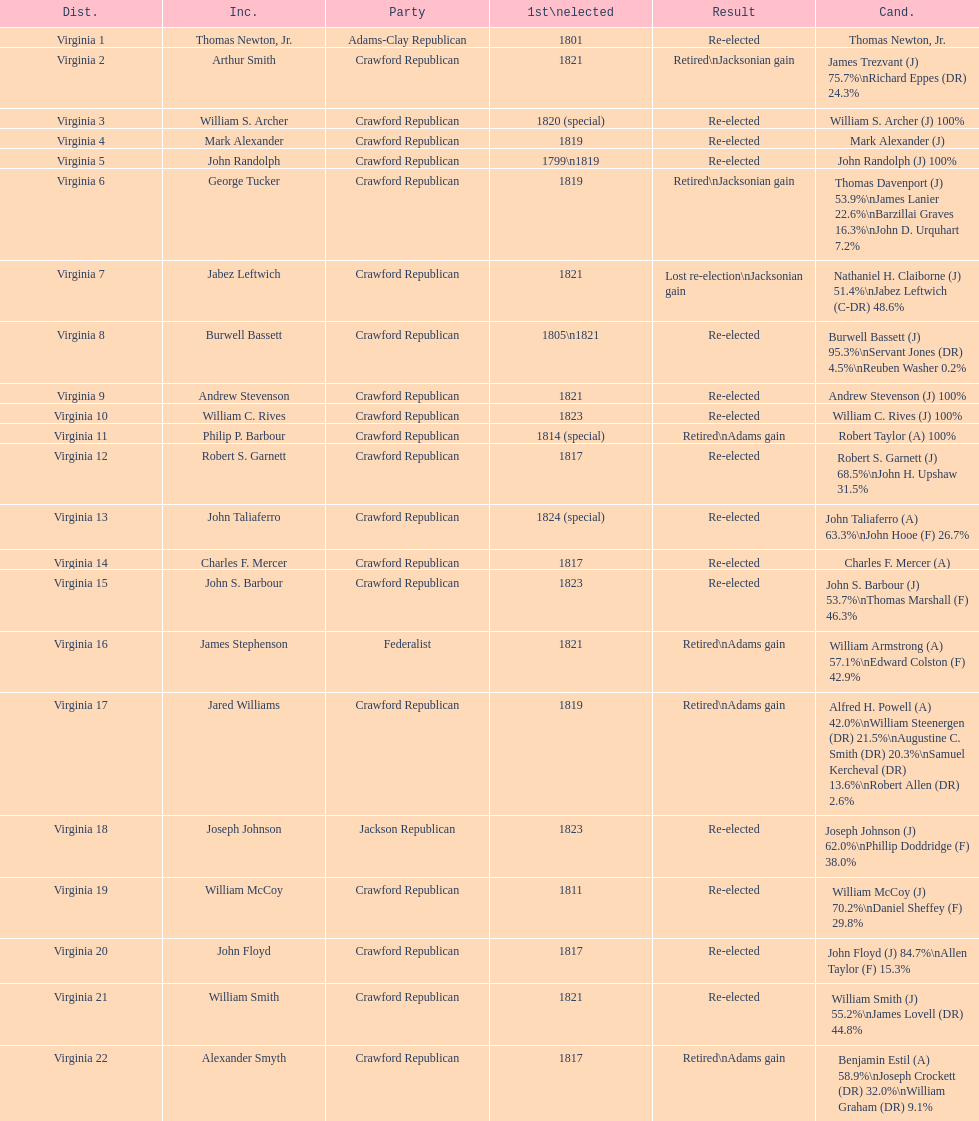Name the only candidate that was first elected in 1811. William McCoy. 